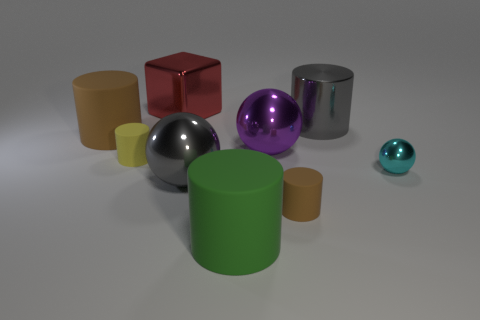There is a green object that is the same shape as the small yellow rubber object; what size is it?
Keep it short and to the point. Large. There is a large gray metal object to the left of the green matte object; what is its shape?
Offer a very short reply. Sphere. Do the large cylinder that is left of the tiny yellow cylinder and the cyan thing that is right of the purple ball have the same material?
Ensure brevity in your answer.  No. There is a green rubber thing; what shape is it?
Offer a terse response. Cylinder. Are there the same number of tiny shiny balls that are on the right side of the cyan ball and small green metal things?
Your response must be concise. Yes. There is a metal thing that is the same color as the big metal cylinder; what size is it?
Your answer should be very brief. Large. Are there any blue blocks made of the same material as the large brown cylinder?
Your answer should be compact. No. Do the tiny brown matte thing that is to the right of the large purple metallic ball and the brown rubber object that is on the left side of the red metal block have the same shape?
Provide a short and direct response. Yes. Are there any tiny blue rubber cubes?
Offer a very short reply. No. There is a cube that is the same size as the purple metal thing; what color is it?
Ensure brevity in your answer.  Red. 